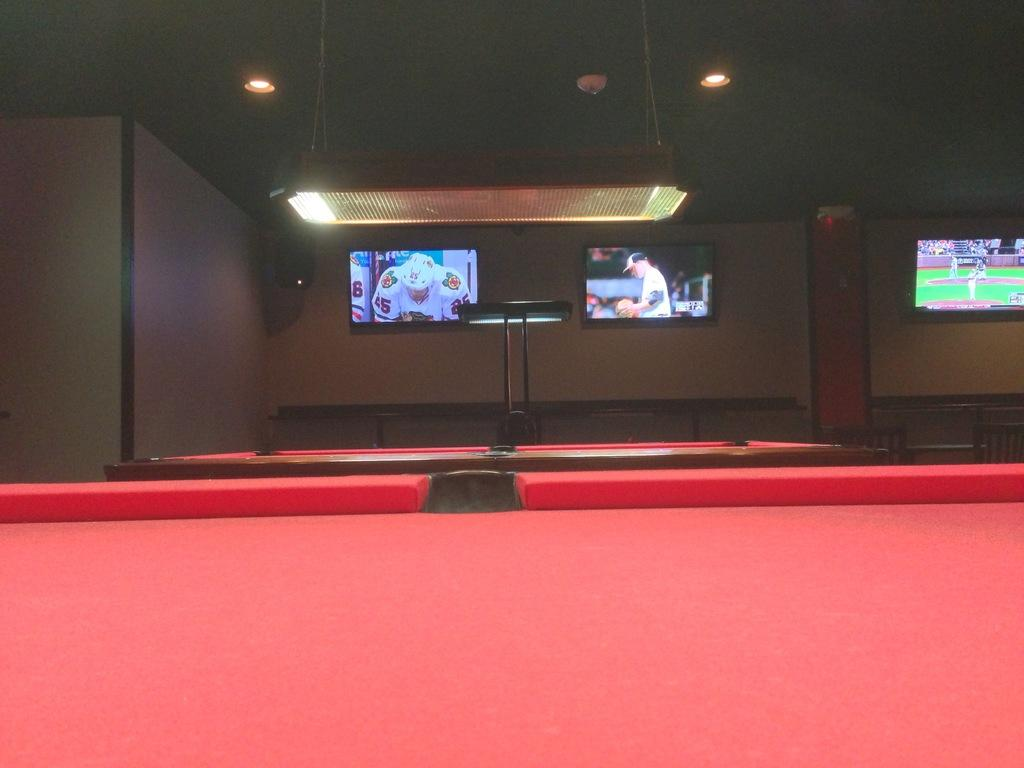How many televisions are visible in the image? There are three televisions in the image. Can you describe the lighting in the image? There is light in the image. What is the color of the table in front of the televisions? The table is red. What else can be seen in the image that is alight? There is an object that appears to be alight in the image. Can you tell me how many basketballs are on the red table in the image? There is no basketball present on the red table in the image. Is there a coach visible in the image? There is no coach present in the image. 